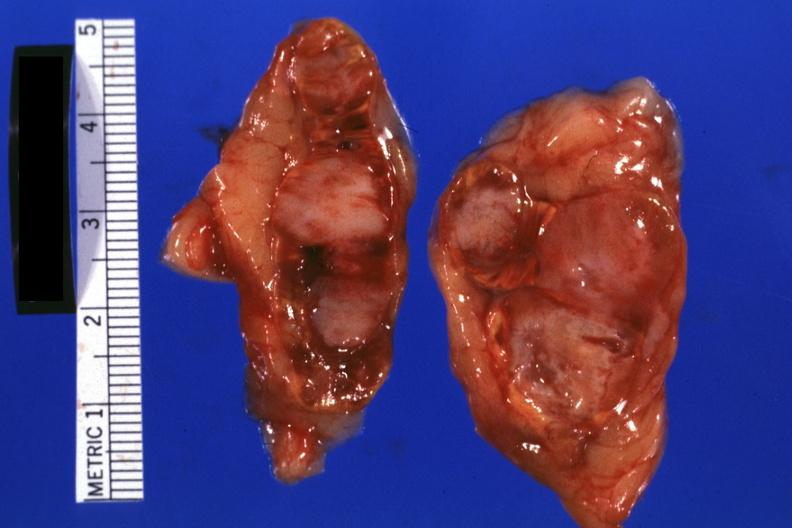s endocrine present?
Answer the question using a single word or phrase. Yes 